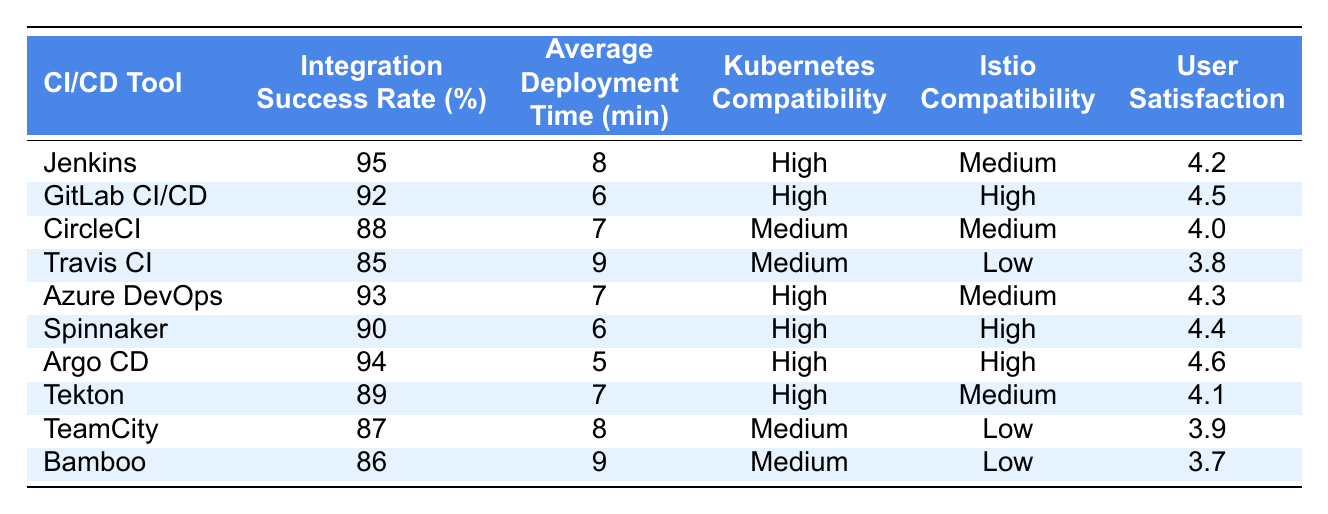What is the integration success rate of GitLab CI/CD? GitLab CI/CD's integration success rate is provided directly in the table, displaying the rate as 92%.
Answer: 92% Which CI/CD tool has the highest user satisfaction rating? By examining the user satisfaction ratings for each tool in the table, Argo CD has the highest rating at 4.6.
Answer: Argo CD What is the average deployment time for Jenkins? The average deployment time for Jenkins is listed in the table as 8 minutes.
Answer: 8 minutes Does Azure DevOps have high compatibility with Istio? The table shows that Azure DevOps has medium compatibility with Istio, indicating that it does not have high compatibility.
Answer: No Which tool has the lowest integration success rate? The integration success rates for all tools were compared, and Travis CI has the lowest rate at 85%.
Answer: Travis CI What is the difference in integration success rates between Jenkins and CircleCI? Jenkins has a success rate of 95% while CircleCI has 88%, resulting in a difference of 95 - 88 = 7%.
Answer: 7% How many tools have high compatibility with both Kubernetes and Istio? The table shows that GitLab CI/CD, Spinnaker, and Argo CD all have high compatibility with both Kubernetes and Istio, making it a total of 3 tools.
Answer: 3 tools What is the average user satisfaction rating for the tools listed in the table? By adding the user satisfaction ratings (4.2, 4.5, 4.0, 3.8, 4.3, 4.4, 4.6, 4.1, 3.9, 3.7 = 43.5) and dividing by 10 (the number of tools), the average is 43.5/10 = 4.35.
Answer: 4.35 Which tools have an average deployment time less than 7 minutes? By scanning through the table, Argo CD and GitLab CI/CD have average deployment times of 5 and 6 minutes respectively.
Answer: Argo CD and GitLab CI/CD Are there any CI/CD tools that have high compatibility with Kubernetes but low compatibility with Istio? The table indicates that TeamCity and Bamboo have medium Kubernetes compatibility and low Istio compatibility, answering yes to the question.
Answer: Yes 